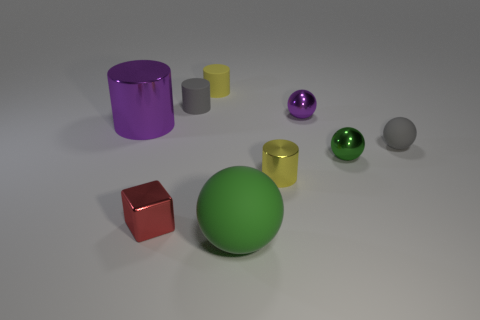Subtract 1 cylinders. How many cylinders are left? 3 Add 1 red shiny objects. How many objects exist? 10 Subtract all cyan balls. Subtract all red cylinders. How many balls are left? 4 Subtract all spheres. How many objects are left? 5 Add 2 red blocks. How many red blocks are left? 3 Add 3 purple metal balls. How many purple metal balls exist? 4 Subtract 0 red cylinders. How many objects are left? 9 Subtract all tiny things. Subtract all purple metal cylinders. How many objects are left? 1 